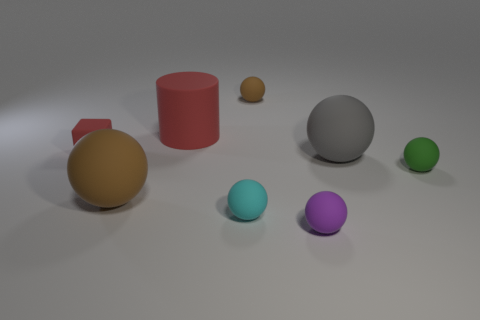Subtract all small brown rubber balls. How many balls are left? 5 Subtract all cyan spheres. How many spheres are left? 5 Add 1 tiny green balls. How many objects exist? 9 Subtract all cyan spheres. Subtract all cyan blocks. How many spheres are left? 5 Subtract all cubes. How many objects are left? 7 Add 7 large red objects. How many large red objects are left? 8 Add 7 green objects. How many green objects exist? 8 Subtract 0 yellow cylinders. How many objects are left? 8 Subtract all tiny red rubber things. Subtract all purple objects. How many objects are left? 6 